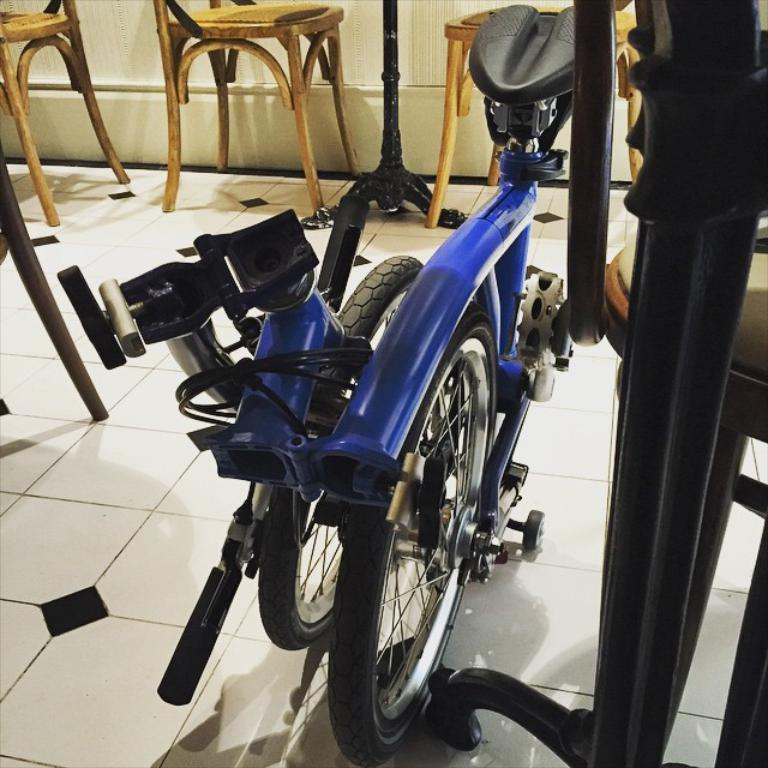What is placed on the floor in the image? There is a bicycle placed on the floor. What can be seen in the background of the image? There are chairs in the background of the image. What type of creature is jumping over the bicycle in the image? There is no creature present in the image, and the bicycle is placed on the floor, not being jumped over. 